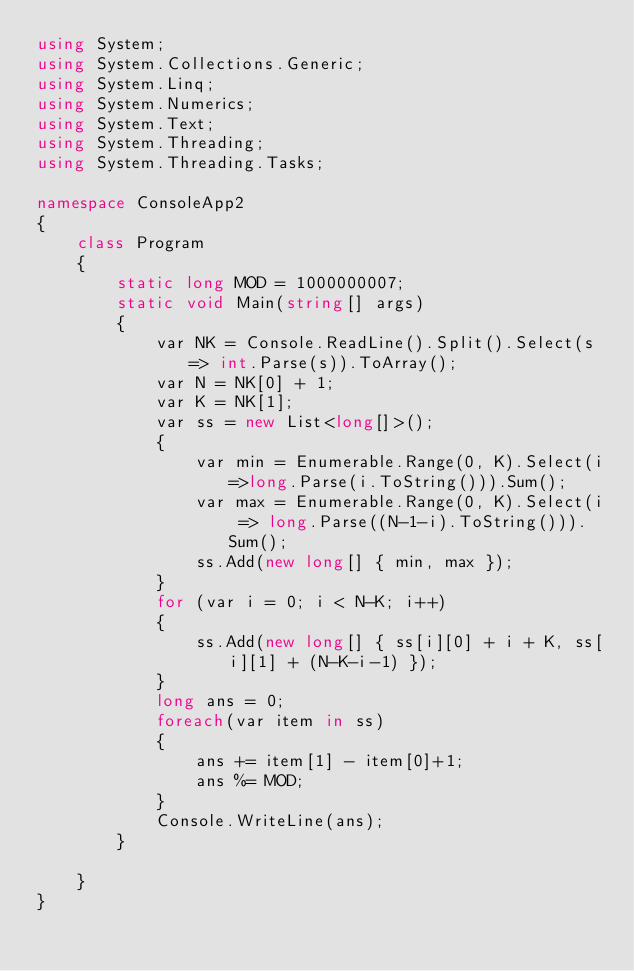<code> <loc_0><loc_0><loc_500><loc_500><_C#_>using System;
using System.Collections.Generic;
using System.Linq;
using System.Numerics;
using System.Text;
using System.Threading;
using System.Threading.Tasks;

namespace ConsoleApp2
{
    class Program
    {
        static long MOD = 1000000007;
        static void Main(string[] args)
        {
            var NK = Console.ReadLine().Split().Select(s => int.Parse(s)).ToArray();
            var N = NK[0] + 1;
            var K = NK[1];
            var ss = new List<long[]>();
            {
                var min = Enumerable.Range(0, K).Select(i=>long.Parse(i.ToString())).Sum();
                var max = Enumerable.Range(0, K).Select(i => long.Parse((N-1-i).ToString())).Sum();
                ss.Add(new long[] { min, max });
            }
            for (var i = 0; i < N-K; i++)
            {
                ss.Add(new long[] { ss[i][0] + i + K, ss[i][1] + (N-K-i-1) });
            }
            long ans = 0;
            foreach(var item in ss)
            {
                ans += item[1] - item[0]+1;
                ans %= MOD;
            }
            Console.WriteLine(ans);
        }

    }
}</code> 